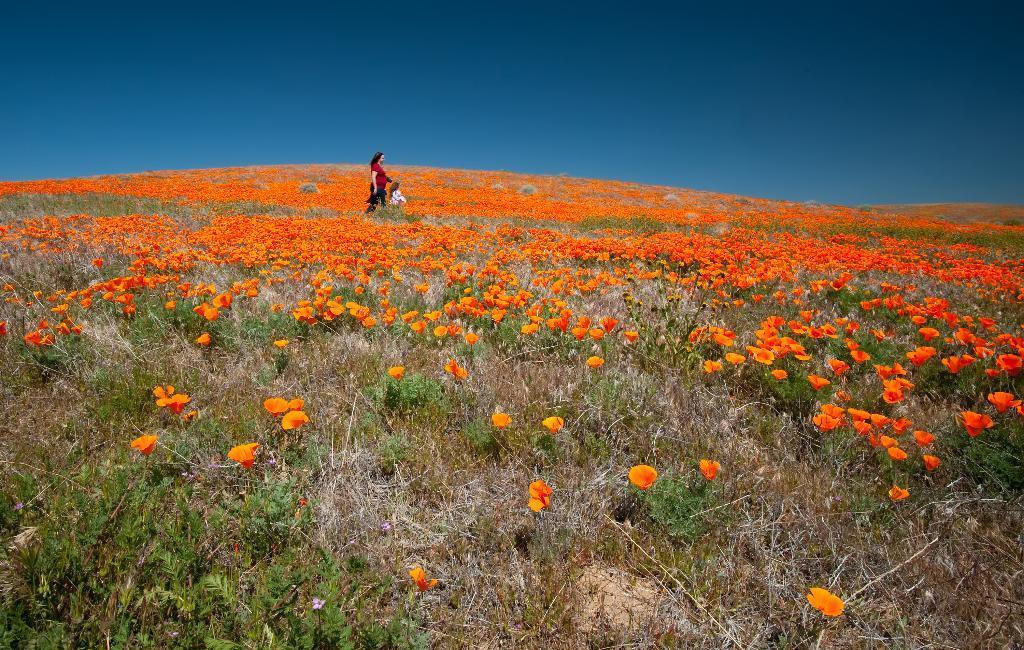How would you summarize this image in a sentence or two? In this image I can see the yellow and orange color flower to the plants. In-between the plants I can see two people with red and white color dresses. In the background I can see the blue sky. 